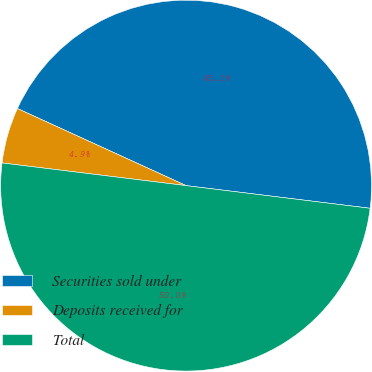Convert chart. <chart><loc_0><loc_0><loc_500><loc_500><pie_chart><fcel>Securities sold under<fcel>Deposits received for<fcel>Total<nl><fcel>45.13%<fcel>4.87%<fcel>50.0%<nl></chart> 